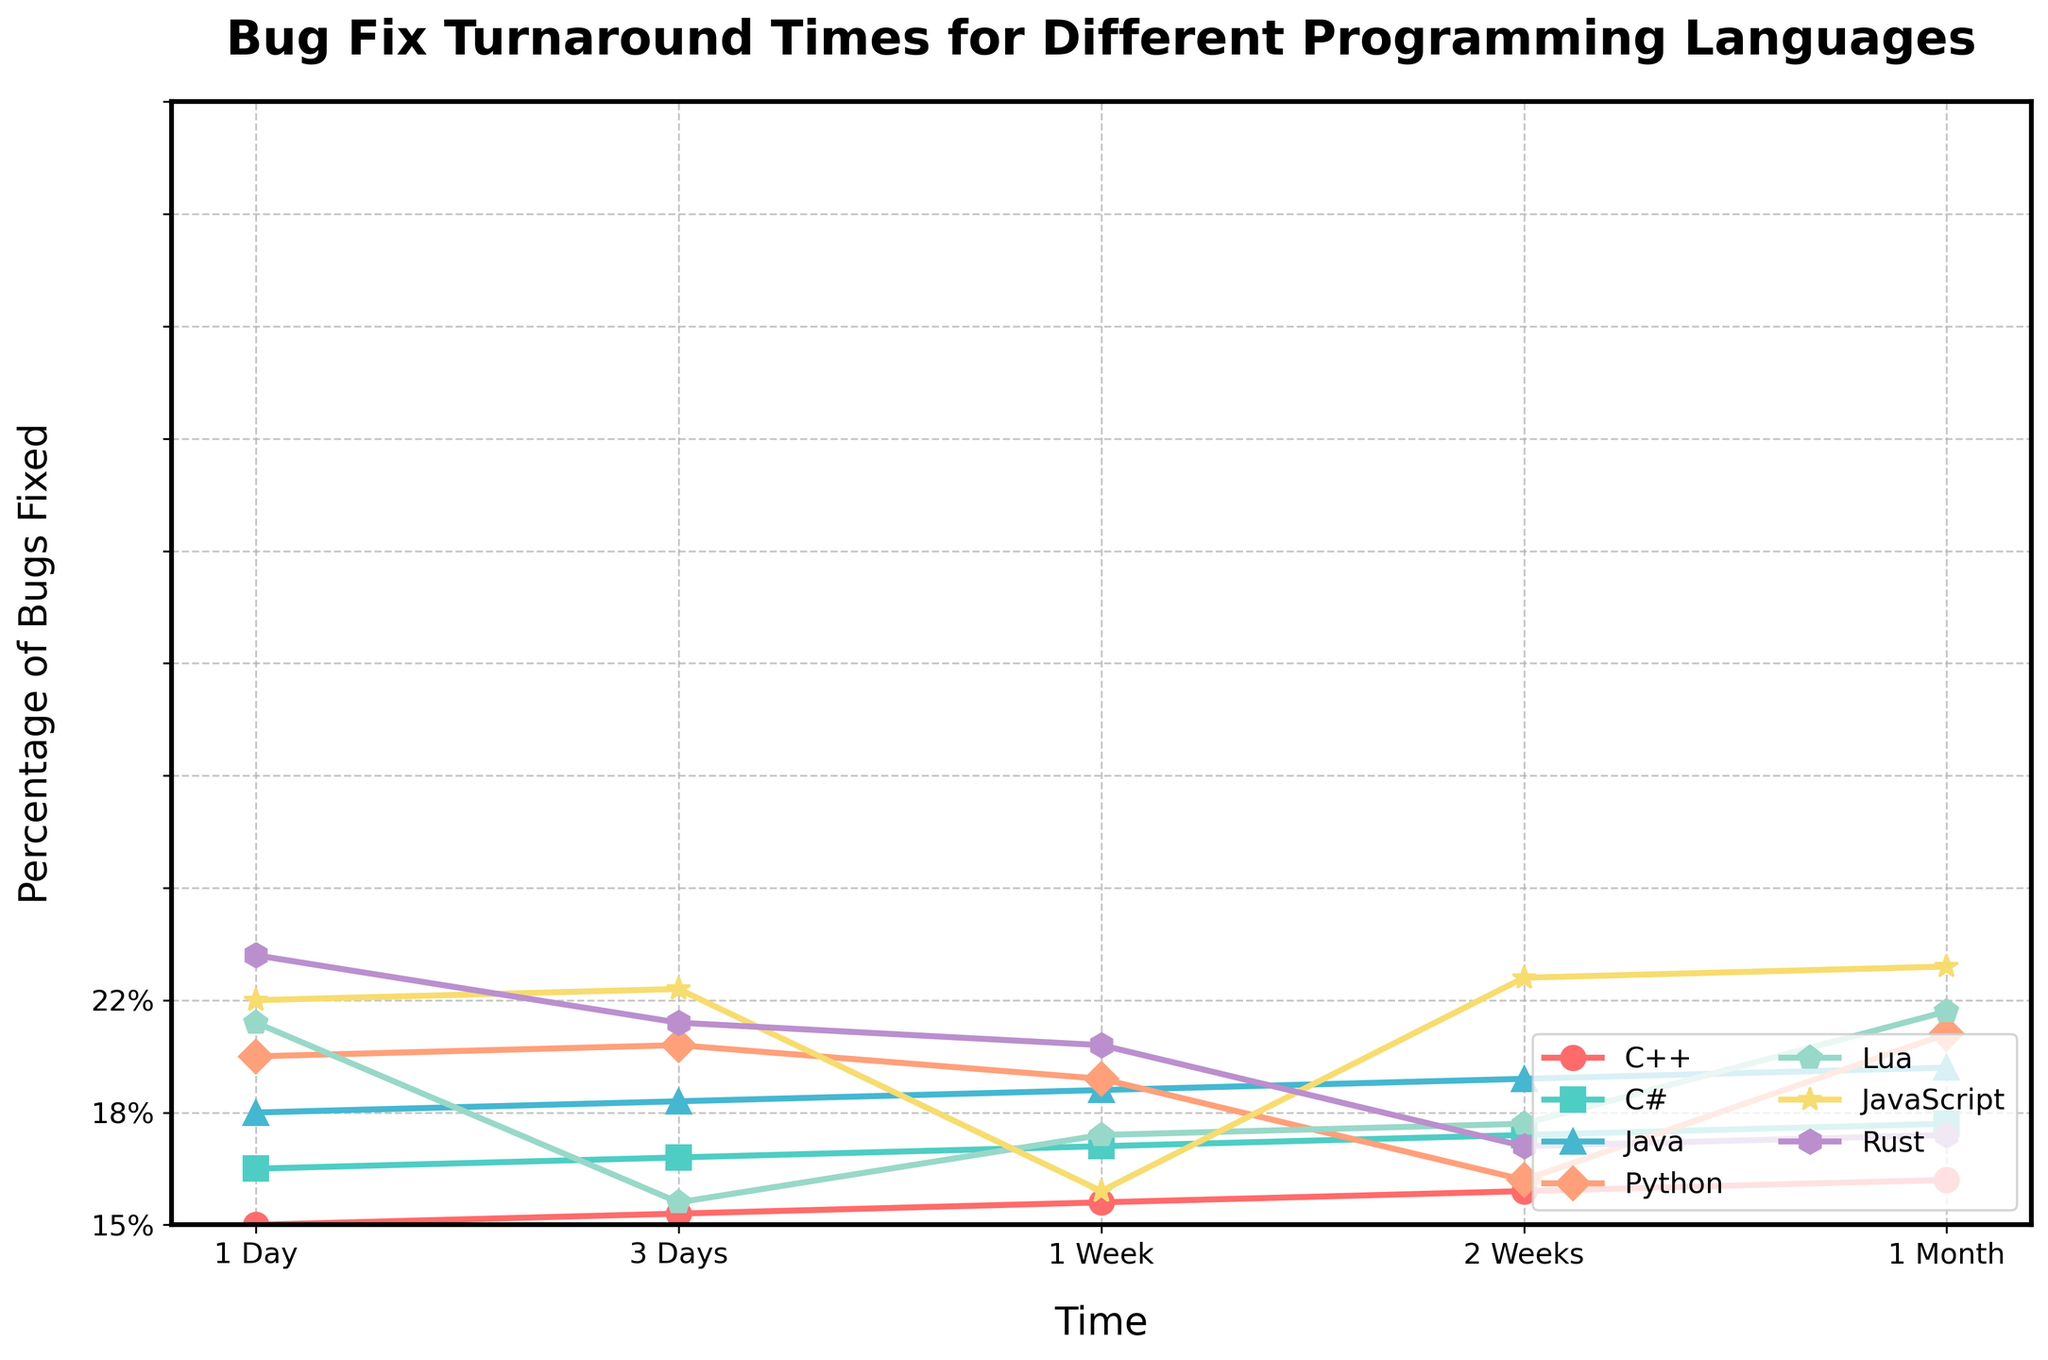Which programming language has the highest percentage of bugs fixed within 1 month? Look at the last points on the graph for each language and find the one with the highest value. Lua has the highest point at 99%.
Answer: Lua Which language shows the smallest percentage of bugs fixed within the first day? Look at the first points on the graph for each language and identify the one with the lowest value. Rust has the smallest point at 12%.
Answer: Rust Compare the percentage of bugs fixed within 1 week between Python and JavaScript. Which one is higher? Locate the percentages for Python and JavaScript at the '1 Week' mark. Python has 80%, while JavaScript has 75%. Thus, Python is higher.
Answer: Python By how much percentage does Lua surpass C++ in bug fixes after 1 month? Find the values for Lua and C++ at the '1 Month' mark. Lua is at 99%, and C++ is at 90%. Subtract 90% from 99% to get the difference.
Answer: 9% Which language has the highest increase in the percentage of bugs fixed from 1 Day to 3 Days? Calculate the differences from '1 Day' to '3 Days' for each language and find the highest one. Lua increases by 30%, which is the highest.
Answer: Lua Compare the trend of Rust and Python in terms of bug fixes across all time intervals. Which language consistently has lower bug fix percentages? Look at the plotted lines for both Rust and Python across all time intervals. Rust consistently has lower percentages compared to Python.
Answer: Rust What is the average percentage of bugs fixed within 2 weeks for all languages? Sum the percentages at the '2 Weeks' mark for all languages and divide by the number of languages (7). (75% + 85% + 80% + 90% + 95% + 88% + 70%) / 7 = 83.29%.
Answer: 83.29% What is the difference in the percentage of bugs fixed within 1 week between C++ and C#? Look at the '1 Week' values for C++ (60%) and C# (70%) and find the difference by subtracting 60% from 70%.
Answer: 10% Which language catches up the most in bug fixes within 1 month compared to its performance within 1 week? Identify the change from '1 Week' to '1 Month' for each language. Rust shows the most significant increase (85% - 55% = 30%).
Answer: Rust What color represents JavaScript in the chart? JavaScript is represented by the purple line. Examine the line color and refer to the labels to identify JavaScript's color.
Answer: Purple 